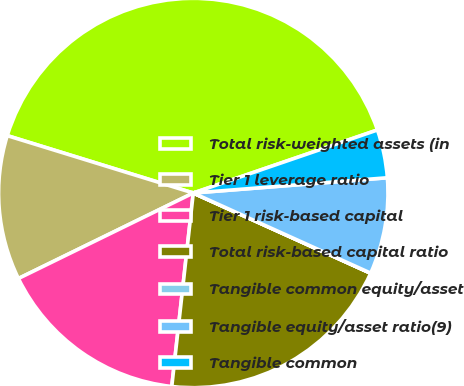Convert chart to OTSL. <chart><loc_0><loc_0><loc_500><loc_500><pie_chart><fcel>Total risk-weighted assets (in<fcel>Tier 1 leverage ratio<fcel>Tier 1 risk-based capital<fcel>Total risk-based capital ratio<fcel>Tangible common equity/asset<fcel>Tangible equity/asset ratio(9)<fcel>Tangible common<nl><fcel>39.99%<fcel>12.0%<fcel>16.0%<fcel>20.0%<fcel>0.01%<fcel>8.0%<fcel>4.0%<nl></chart> 